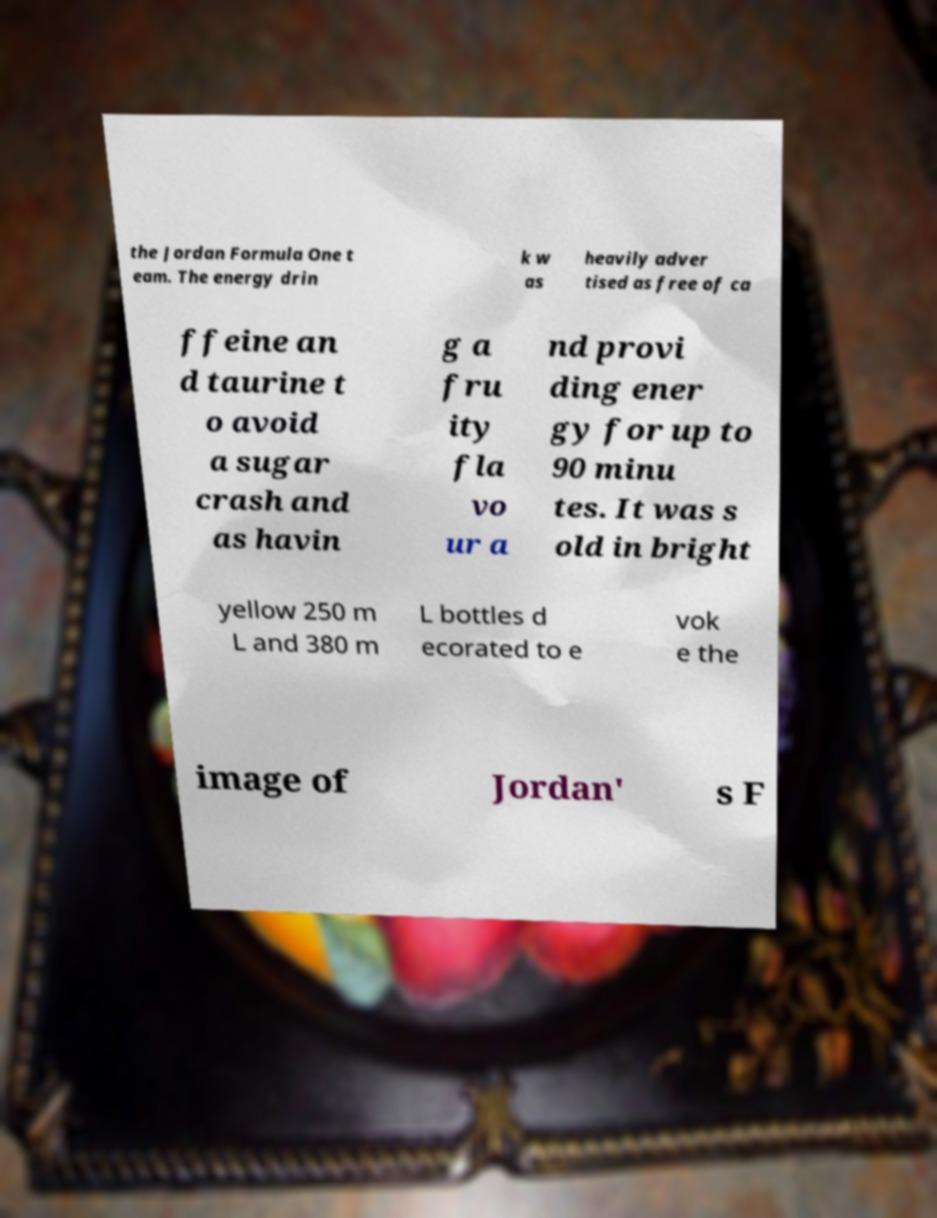What messages or text are displayed in this image? I need them in a readable, typed format. the Jordan Formula One t eam. The energy drin k w as heavily adver tised as free of ca ffeine an d taurine t o avoid a sugar crash and as havin g a fru ity fla vo ur a nd provi ding ener gy for up to 90 minu tes. It was s old in bright yellow 250 m L and 380 m L bottles d ecorated to e vok e the image of Jordan' s F 